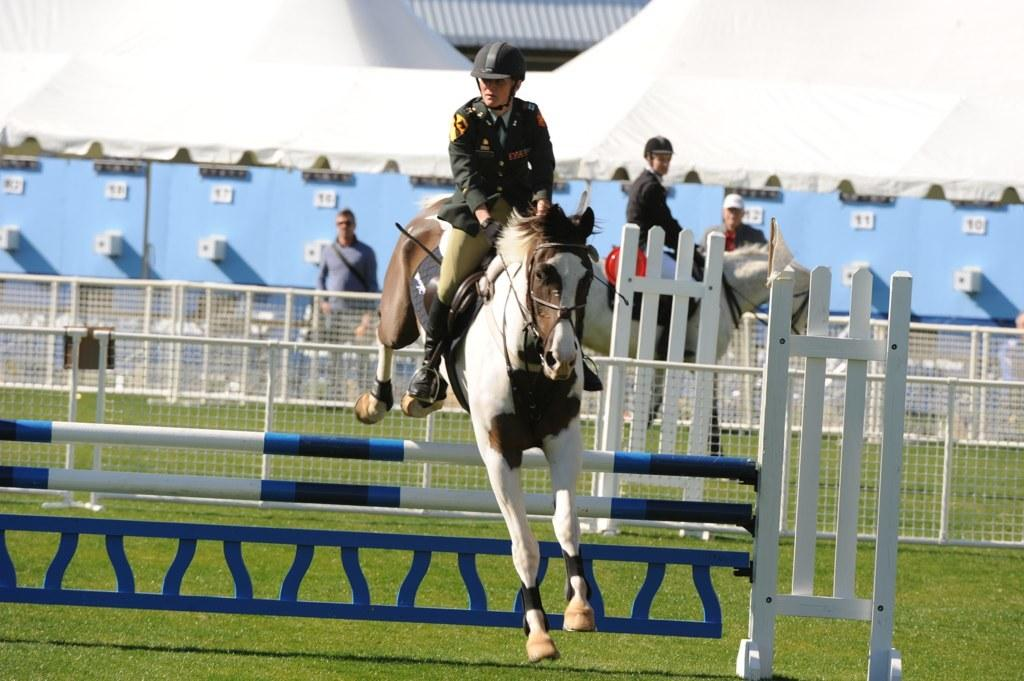Where was the image taken? The image was clicked outside. What animals are present in the image? There are horses in the image. What are the people in the image doing with the horses? People are sitting on the horses. What activity is being depicted in the image? The scene appears to be horse riding. What type of paper is being used to give advice in the image? There is no paper or advice-giving activity present in the image; it features people riding horses. 